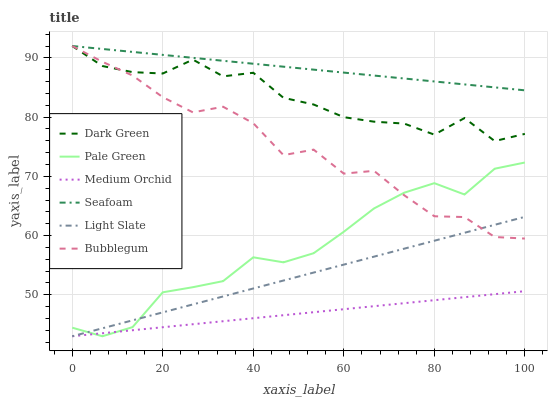Does Medium Orchid have the minimum area under the curve?
Answer yes or no. Yes. Does Seafoam have the maximum area under the curve?
Answer yes or no. Yes. Does Seafoam have the minimum area under the curve?
Answer yes or no. No. Does Medium Orchid have the maximum area under the curve?
Answer yes or no. No. Is Light Slate the smoothest?
Answer yes or no. Yes. Is Bubblegum the roughest?
Answer yes or no. Yes. Is Seafoam the smoothest?
Answer yes or no. No. Is Seafoam the roughest?
Answer yes or no. No. Does Seafoam have the lowest value?
Answer yes or no. No. Does Medium Orchid have the highest value?
Answer yes or no. No. Is Medium Orchid less than Seafoam?
Answer yes or no. Yes. Is Dark Green greater than Pale Green?
Answer yes or no. Yes. Does Medium Orchid intersect Seafoam?
Answer yes or no. No. 